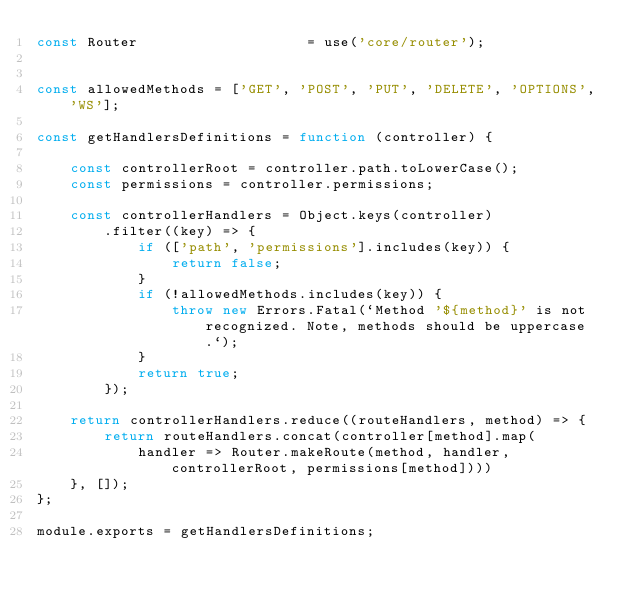<code> <loc_0><loc_0><loc_500><loc_500><_JavaScript_>const Router                    = use('core/router');


const allowedMethods = ['GET', 'POST', 'PUT', 'DELETE', 'OPTIONS', 'WS'];

const getHandlersDefinitions = function (controller) {

    const controllerRoot = controller.path.toLowerCase();
    const permissions = controller.permissions;

    const controllerHandlers = Object.keys(controller)
        .filter((key) => {
            if (['path', 'permissions'].includes(key)) {
                return false;
            }
            if (!allowedMethods.includes(key)) {
                throw new Errors.Fatal(`Method '${method}' is not recognized. Note, methods should be uppercase.`);
            }
            return true;
        });

    return controllerHandlers.reduce((routeHandlers, method) => {
        return routeHandlers.concat(controller[method].map(
            handler => Router.makeRoute(method, handler, controllerRoot, permissions[method])))
    }, []);
};

module.exports = getHandlersDefinitions;

</code> 